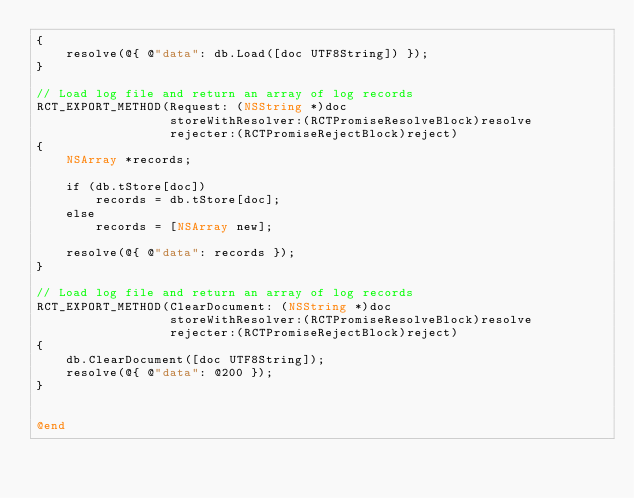Convert code to text. <code><loc_0><loc_0><loc_500><loc_500><_ObjectiveC_>{
    resolve(@{ @"data": db.Load([doc UTF8String]) });
}

// Load log file and return an array of log records
RCT_EXPORT_METHOD(Request: (NSString *)doc
                  storeWithResolver:(RCTPromiseResolveBlock)resolve
                  rejecter:(RCTPromiseRejectBlock)reject)
{
    NSArray *records;
    
    if (db.tStore[doc])
        records = db.tStore[doc];
    else
        records = [NSArray new];
    
    resolve(@{ @"data": records });
}

// Load log file and return an array of log records
RCT_EXPORT_METHOD(ClearDocument: (NSString *)doc
                  storeWithResolver:(RCTPromiseResolveBlock)resolve
                  rejecter:(RCTPromiseRejectBlock)reject)
{
    db.ClearDocument([doc UTF8String]);
    resolve(@{ @"data": @200 });
}


@end

</code> 